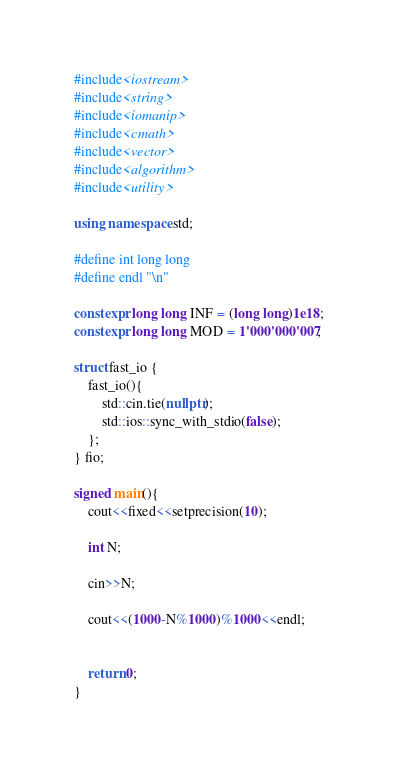<code> <loc_0><loc_0><loc_500><loc_500><_C++_>#include<iostream>
#include<string>
#include<iomanip>
#include<cmath>
#include<vector>
#include<algorithm>
#include<utility>

using namespace std;

#define int long long
#define endl "\n"

constexpr long long INF = (long long)1e18;
constexpr long long MOD = 1'000'000'007; 

struct fast_io {
	fast_io(){
		std::cin.tie(nullptr);
		std::ios::sync_with_stdio(false);
	};
} fio;

signed main(){
	cout<<fixed<<setprecision(10);
	
	int N;
	
	cin>>N;
	
	cout<<(1000-N%1000)%1000<<endl;
	
	
	return 0;
}</code> 